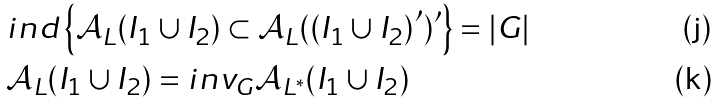Convert formula to latex. <formula><loc_0><loc_0><loc_500><loc_500>& i n d \left \{ \mathcal { A } _ { L } ( I _ { 1 } \cup I _ { 2 } ) \subset \mathcal { A } _ { L } ( \left ( I _ { 1 } \cup I _ { 2 } \right ) ^ { \prime } ) ^ { \prime } \right \} = \left | G \right | \\ & \mathcal { A } _ { L } ( I _ { 1 } \cup I _ { 2 } ) = i n v _ { G } \mathcal { A } _ { L ^ { \ast } } ( I _ { 1 } \cup I _ { 2 } )</formula> 